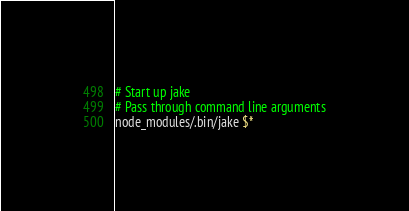Convert code to text. <code><loc_0><loc_0><loc_500><loc_500><_Bash_># Start up jake
# Pass through command line arguments
node_modules/.bin/jake $*
</code> 